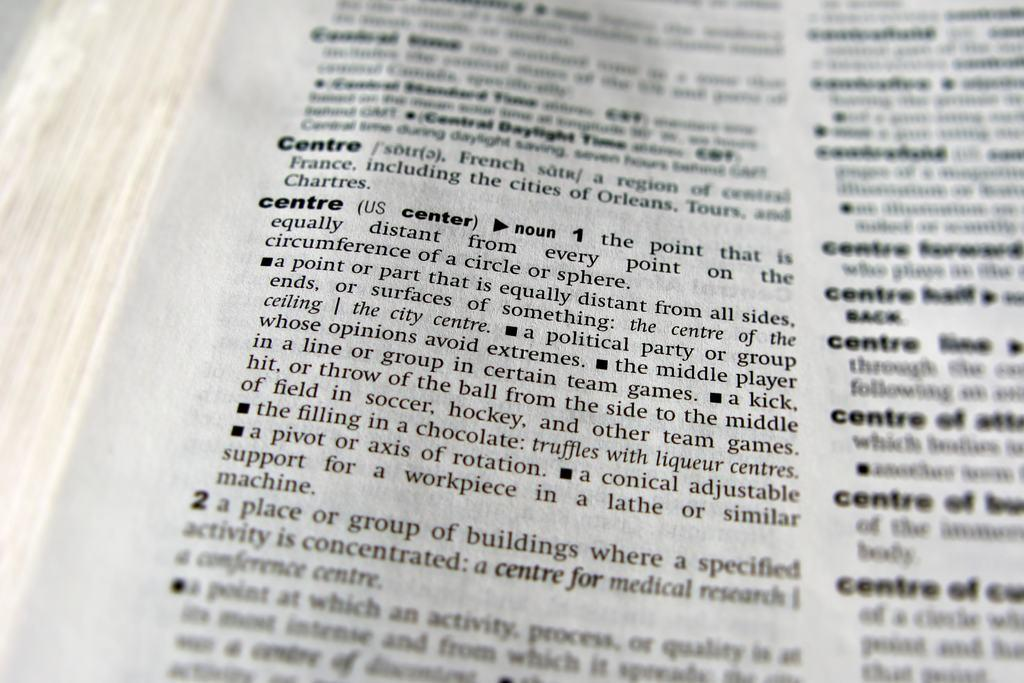<image>
Present a compact description of the photo's key features. A dictionary displaying various definitions and uses of the word centre 